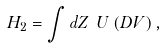<formula> <loc_0><loc_0><loc_500><loc_500>H _ { 2 } = \int d Z \ U \left ( D V \right ) ,</formula> 